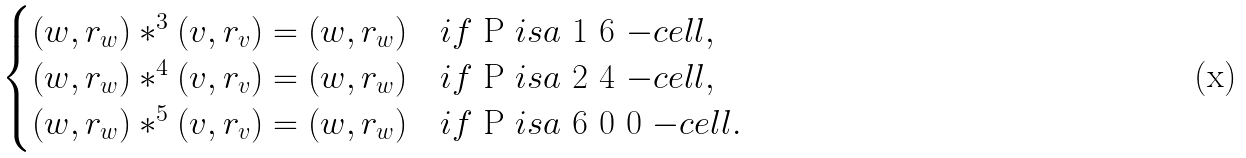Convert formula to latex. <formula><loc_0><loc_0><loc_500><loc_500>\begin{cases} ( w , r _ { w } ) \ast ^ { 3 } ( v , r _ { v } ) = ( w , r _ { w } ) \quad i f $ P $ i s a $ 1 6 $ - c e l l , \\ ( w , r _ { w } ) \ast ^ { 4 } ( v , r _ { v } ) = ( w , r _ { w } ) \quad i f $ P $ i s a $ 2 4 $ - c e l l , \\ ( w , r _ { w } ) \ast ^ { 5 } ( v , r _ { v } ) = ( w , r _ { w } ) \quad i f $ P $ i s a $ 6 0 0 $ - c e l l . \end{cases}</formula> 